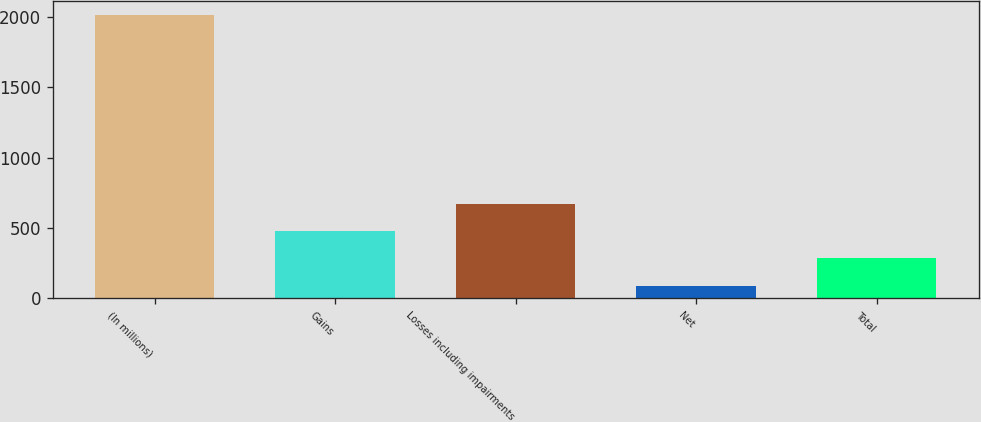<chart> <loc_0><loc_0><loc_500><loc_500><bar_chart><fcel>(In millions)<fcel>Gains<fcel>Losses including impairments<fcel>Net<fcel>Total<nl><fcel>2010<fcel>474.8<fcel>666.7<fcel>91<fcel>282.9<nl></chart> 